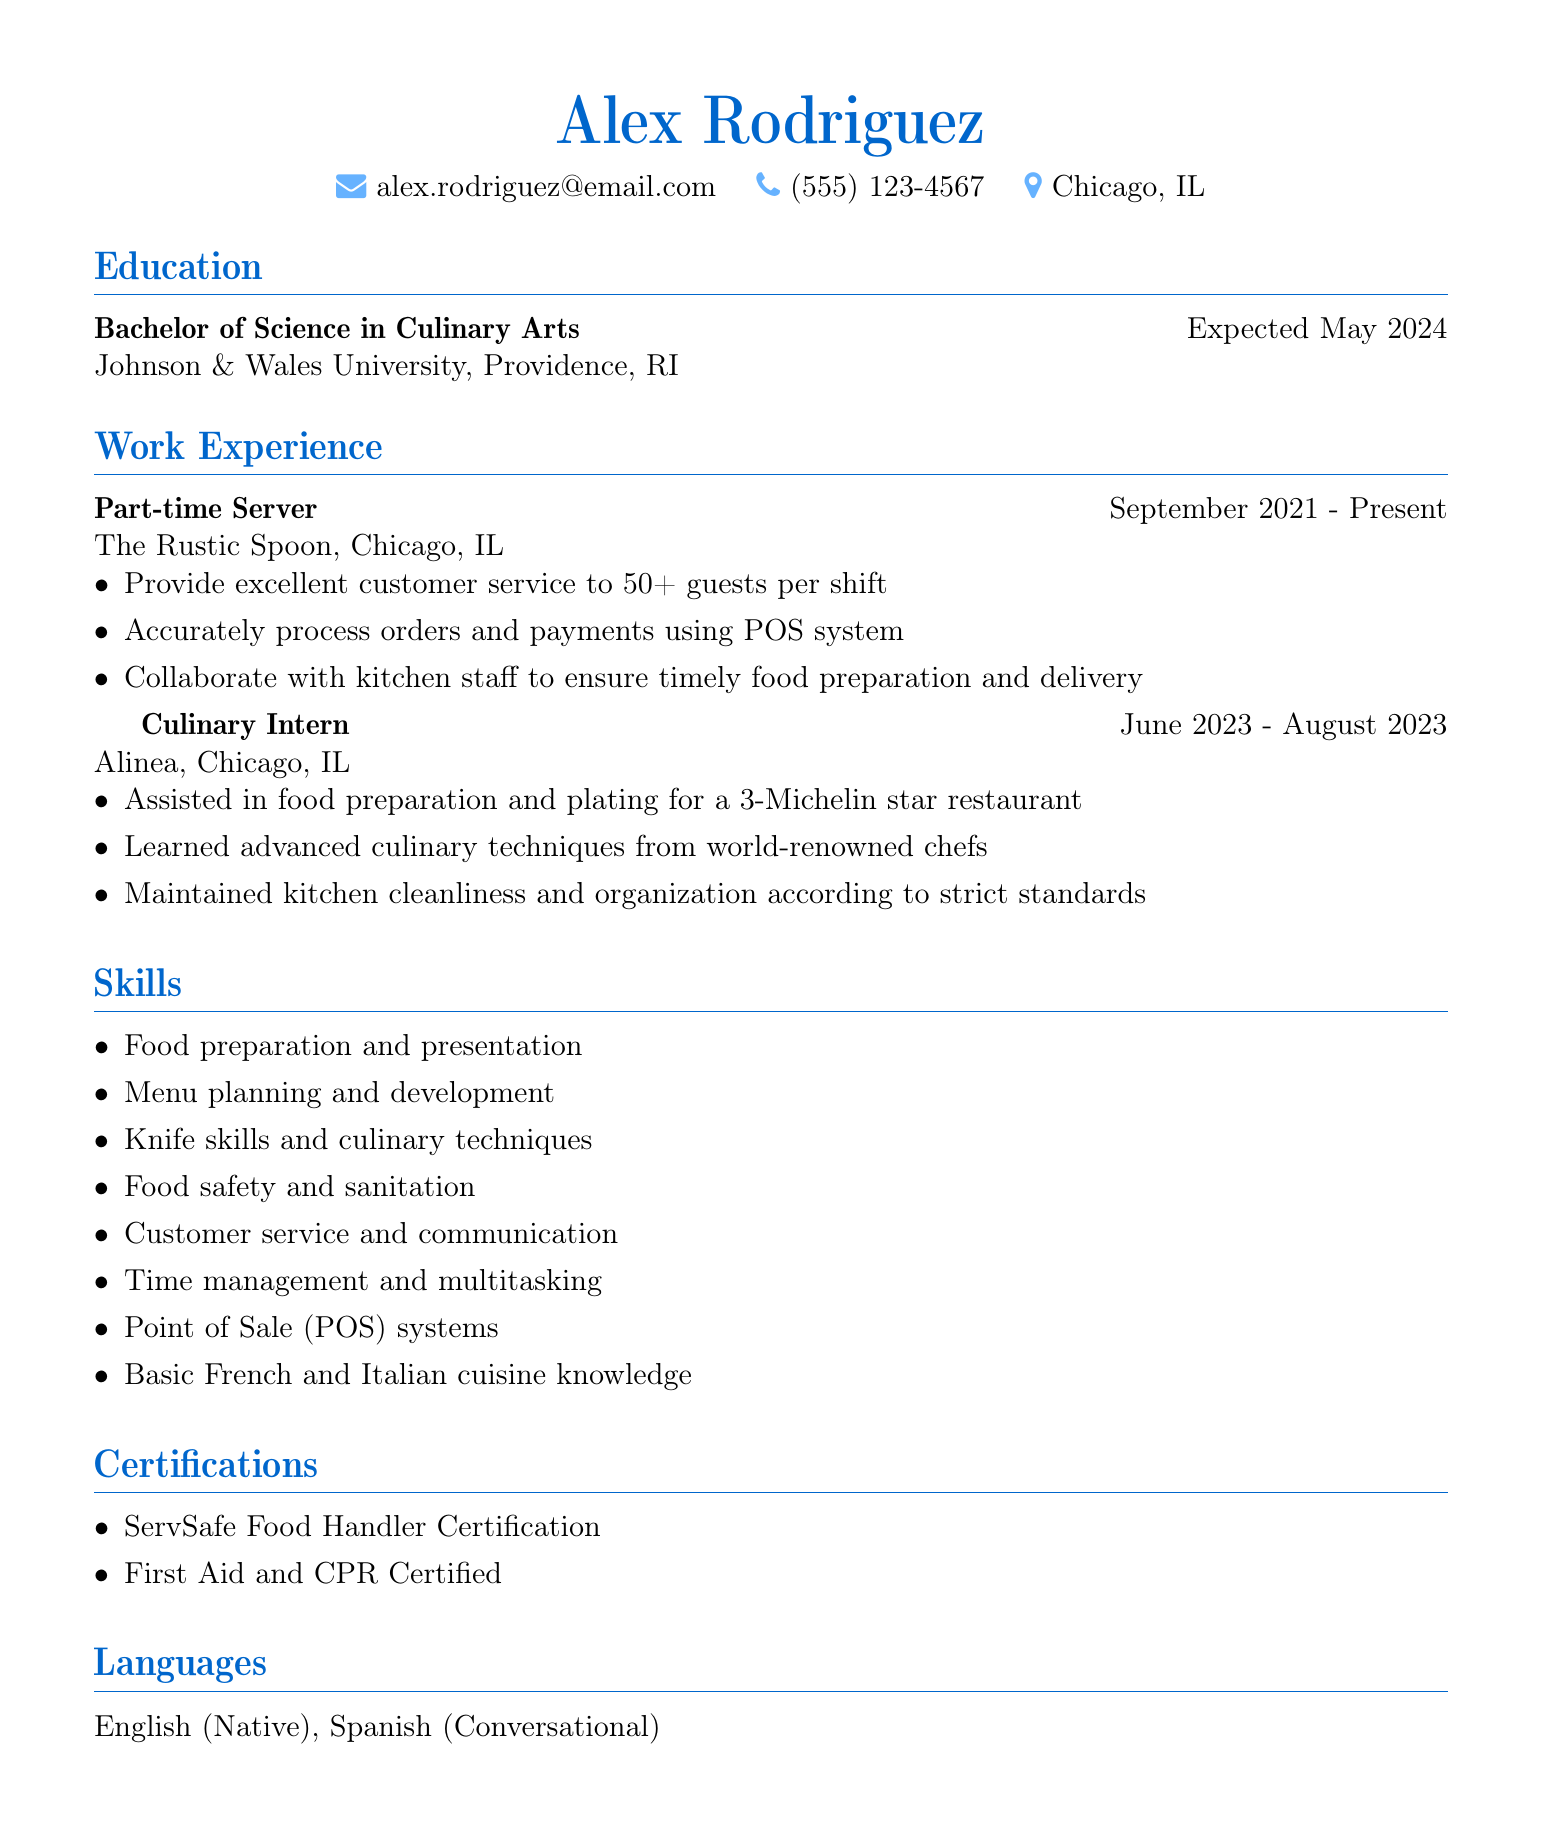What is the name of the applicant? The applicant's name is highlighted in the document as the first line.
Answer: Alex Rodriguez What is the applicant’s expected graduation date? The expected graduation date is listed under the education section.
Answer: Expected May 2024 What position does the applicant currently hold? The current position is mentioned in the work experience section, specifically for the first job listed.
Answer: Part-time Server Which restaurant did the applicant intern at? The name of the restaurant is provided in the work experience section under the culinary intern position.
Answer: Alinea How many guests does the applicant serve per shift? This information is included in the responsibilities of the current job under work experience.
Answer: 50+ What type of cuisine knowledge does the applicant possess? The type of cuisine knowledge is mentioned in the skills section at the end of the document.
Answer: Basic French and Italian cuisine knowledge What certification does the applicant hold related to food handling? The certification type is listed in the certifications section of the resume.
Answer: ServSafe Food Handler Certification What essential skill is emphasized in the document alongside culinary skills? This skill is highlighted in the skills section of the resume alongside culinary techniques.
Answer: Customer service and communication How long did the culinary internship last? The duration is calculated based on the start and end dates provided in the work experience section.
Answer: June 2023 - August 2023 